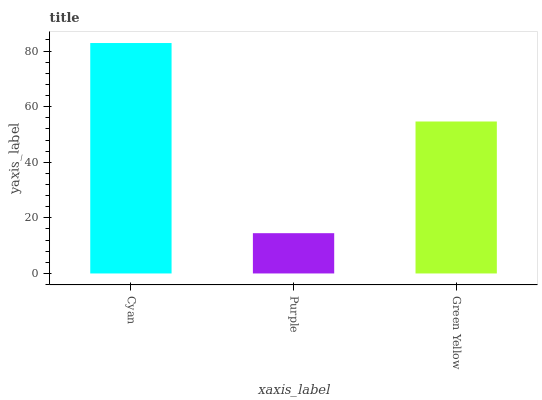Is Purple the minimum?
Answer yes or no. Yes. Is Cyan the maximum?
Answer yes or no. Yes. Is Green Yellow the minimum?
Answer yes or no. No. Is Green Yellow the maximum?
Answer yes or no. No. Is Green Yellow greater than Purple?
Answer yes or no. Yes. Is Purple less than Green Yellow?
Answer yes or no. Yes. Is Purple greater than Green Yellow?
Answer yes or no. No. Is Green Yellow less than Purple?
Answer yes or no. No. Is Green Yellow the high median?
Answer yes or no. Yes. Is Green Yellow the low median?
Answer yes or no. Yes. Is Cyan the high median?
Answer yes or no. No. Is Purple the low median?
Answer yes or no. No. 